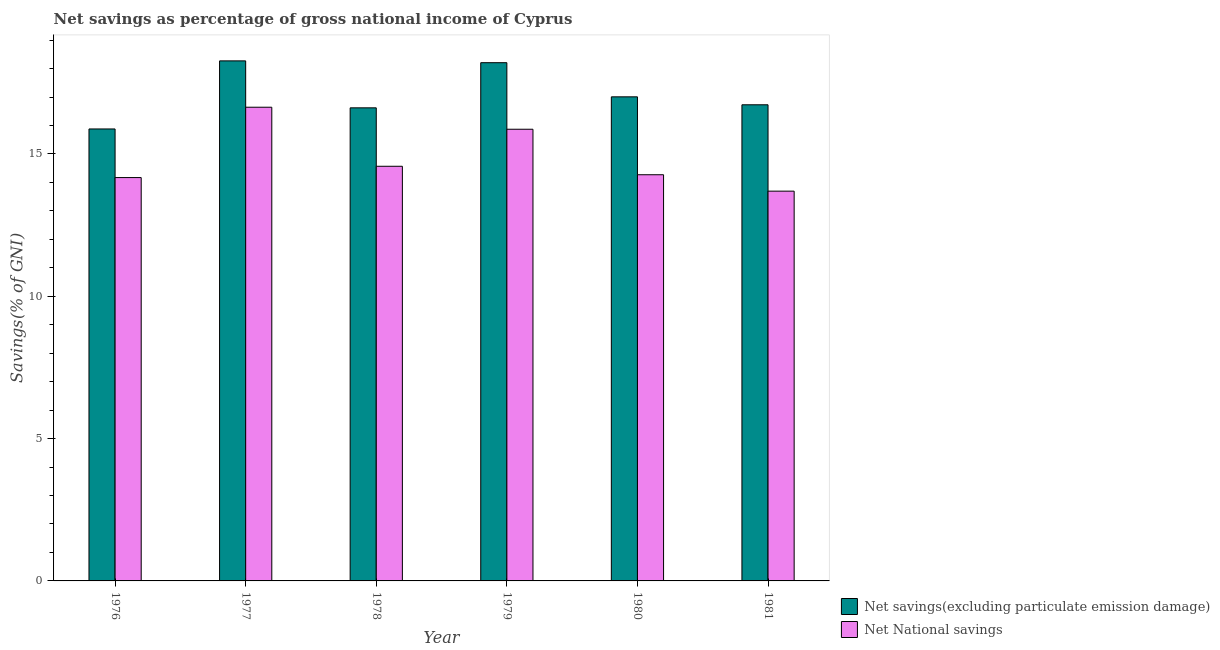How many different coloured bars are there?
Your answer should be very brief. 2. How many bars are there on the 5th tick from the left?
Provide a short and direct response. 2. How many bars are there on the 3rd tick from the right?
Keep it short and to the point. 2. What is the label of the 6th group of bars from the left?
Keep it short and to the point. 1981. What is the net savings(excluding particulate emission damage) in 1976?
Keep it short and to the point. 15.88. Across all years, what is the maximum net savings(excluding particulate emission damage)?
Your response must be concise. 18.27. Across all years, what is the minimum net savings(excluding particulate emission damage)?
Make the answer very short. 15.88. In which year was the net national savings maximum?
Give a very brief answer. 1977. What is the total net national savings in the graph?
Your response must be concise. 89.21. What is the difference between the net savings(excluding particulate emission damage) in 1976 and that in 1980?
Make the answer very short. -1.13. What is the difference between the net national savings in 1979 and the net savings(excluding particulate emission damage) in 1976?
Make the answer very short. 1.7. What is the average net national savings per year?
Your answer should be compact. 14.87. In the year 1981, what is the difference between the net savings(excluding particulate emission damage) and net national savings?
Provide a short and direct response. 0. What is the ratio of the net savings(excluding particulate emission damage) in 1976 to that in 1980?
Give a very brief answer. 0.93. Is the net national savings in 1976 less than that in 1980?
Make the answer very short. Yes. What is the difference between the highest and the second highest net savings(excluding particulate emission damage)?
Your answer should be very brief. 0.06. What is the difference between the highest and the lowest net savings(excluding particulate emission damage)?
Keep it short and to the point. 2.39. In how many years, is the net savings(excluding particulate emission damage) greater than the average net savings(excluding particulate emission damage) taken over all years?
Keep it short and to the point. 2. What does the 1st bar from the left in 1977 represents?
Ensure brevity in your answer.  Net savings(excluding particulate emission damage). What does the 2nd bar from the right in 1977 represents?
Offer a very short reply. Net savings(excluding particulate emission damage). Are the values on the major ticks of Y-axis written in scientific E-notation?
Offer a terse response. No. How many legend labels are there?
Your response must be concise. 2. What is the title of the graph?
Make the answer very short. Net savings as percentage of gross national income of Cyprus. Does "Secondary" appear as one of the legend labels in the graph?
Your answer should be very brief. No. What is the label or title of the X-axis?
Ensure brevity in your answer.  Year. What is the label or title of the Y-axis?
Offer a terse response. Savings(% of GNI). What is the Savings(% of GNI) of Net savings(excluding particulate emission damage) in 1976?
Your response must be concise. 15.88. What is the Savings(% of GNI) in Net National savings in 1976?
Offer a terse response. 14.17. What is the Savings(% of GNI) in Net savings(excluding particulate emission damage) in 1977?
Give a very brief answer. 18.27. What is the Savings(% of GNI) in Net National savings in 1977?
Give a very brief answer. 16.64. What is the Savings(% of GNI) of Net savings(excluding particulate emission damage) in 1978?
Your response must be concise. 16.62. What is the Savings(% of GNI) in Net National savings in 1978?
Provide a succinct answer. 14.57. What is the Savings(% of GNI) in Net savings(excluding particulate emission damage) in 1979?
Provide a succinct answer. 18.21. What is the Savings(% of GNI) of Net National savings in 1979?
Your response must be concise. 15.87. What is the Savings(% of GNI) of Net savings(excluding particulate emission damage) in 1980?
Provide a short and direct response. 17.01. What is the Savings(% of GNI) of Net National savings in 1980?
Provide a short and direct response. 14.27. What is the Savings(% of GNI) in Net savings(excluding particulate emission damage) in 1981?
Your answer should be very brief. 16.73. What is the Savings(% of GNI) in Net National savings in 1981?
Your answer should be very brief. 13.69. Across all years, what is the maximum Savings(% of GNI) of Net savings(excluding particulate emission damage)?
Give a very brief answer. 18.27. Across all years, what is the maximum Savings(% of GNI) of Net National savings?
Offer a very short reply. 16.64. Across all years, what is the minimum Savings(% of GNI) of Net savings(excluding particulate emission damage)?
Your answer should be compact. 15.88. Across all years, what is the minimum Savings(% of GNI) of Net National savings?
Give a very brief answer. 13.69. What is the total Savings(% of GNI) of Net savings(excluding particulate emission damage) in the graph?
Offer a very short reply. 102.71. What is the total Savings(% of GNI) in Net National savings in the graph?
Your answer should be very brief. 89.21. What is the difference between the Savings(% of GNI) of Net savings(excluding particulate emission damage) in 1976 and that in 1977?
Offer a terse response. -2.39. What is the difference between the Savings(% of GNI) in Net National savings in 1976 and that in 1977?
Ensure brevity in your answer.  -2.47. What is the difference between the Savings(% of GNI) of Net savings(excluding particulate emission damage) in 1976 and that in 1978?
Provide a succinct answer. -0.74. What is the difference between the Savings(% of GNI) in Net National savings in 1976 and that in 1978?
Offer a terse response. -0.4. What is the difference between the Savings(% of GNI) in Net savings(excluding particulate emission damage) in 1976 and that in 1979?
Give a very brief answer. -2.33. What is the difference between the Savings(% of GNI) of Net National savings in 1976 and that in 1979?
Offer a very short reply. -1.7. What is the difference between the Savings(% of GNI) of Net savings(excluding particulate emission damage) in 1976 and that in 1980?
Your answer should be compact. -1.13. What is the difference between the Savings(% of GNI) in Net National savings in 1976 and that in 1980?
Offer a very short reply. -0.1. What is the difference between the Savings(% of GNI) in Net savings(excluding particulate emission damage) in 1976 and that in 1981?
Your response must be concise. -0.85. What is the difference between the Savings(% of GNI) of Net National savings in 1976 and that in 1981?
Give a very brief answer. 0.48. What is the difference between the Savings(% of GNI) in Net savings(excluding particulate emission damage) in 1977 and that in 1978?
Provide a short and direct response. 1.65. What is the difference between the Savings(% of GNI) in Net National savings in 1977 and that in 1978?
Offer a very short reply. 2.07. What is the difference between the Savings(% of GNI) in Net savings(excluding particulate emission damage) in 1977 and that in 1979?
Your answer should be very brief. 0.06. What is the difference between the Savings(% of GNI) in Net National savings in 1977 and that in 1979?
Provide a short and direct response. 0.77. What is the difference between the Savings(% of GNI) of Net savings(excluding particulate emission damage) in 1977 and that in 1980?
Your response must be concise. 1.26. What is the difference between the Savings(% of GNI) of Net National savings in 1977 and that in 1980?
Provide a succinct answer. 2.37. What is the difference between the Savings(% of GNI) in Net savings(excluding particulate emission damage) in 1977 and that in 1981?
Provide a short and direct response. 1.54. What is the difference between the Savings(% of GNI) of Net National savings in 1977 and that in 1981?
Provide a short and direct response. 2.95. What is the difference between the Savings(% of GNI) of Net savings(excluding particulate emission damage) in 1978 and that in 1979?
Your answer should be very brief. -1.59. What is the difference between the Savings(% of GNI) in Net National savings in 1978 and that in 1979?
Your answer should be compact. -1.3. What is the difference between the Savings(% of GNI) of Net savings(excluding particulate emission damage) in 1978 and that in 1980?
Offer a very short reply. -0.39. What is the difference between the Savings(% of GNI) of Net National savings in 1978 and that in 1980?
Your answer should be compact. 0.3. What is the difference between the Savings(% of GNI) in Net savings(excluding particulate emission damage) in 1978 and that in 1981?
Provide a short and direct response. -0.11. What is the difference between the Savings(% of GNI) of Net National savings in 1978 and that in 1981?
Keep it short and to the point. 0.87. What is the difference between the Savings(% of GNI) in Net savings(excluding particulate emission damage) in 1979 and that in 1980?
Offer a terse response. 1.2. What is the difference between the Savings(% of GNI) of Net National savings in 1979 and that in 1980?
Keep it short and to the point. 1.6. What is the difference between the Savings(% of GNI) of Net savings(excluding particulate emission damage) in 1979 and that in 1981?
Keep it short and to the point. 1.48. What is the difference between the Savings(% of GNI) of Net National savings in 1979 and that in 1981?
Give a very brief answer. 2.17. What is the difference between the Savings(% of GNI) of Net savings(excluding particulate emission damage) in 1980 and that in 1981?
Ensure brevity in your answer.  0.28. What is the difference between the Savings(% of GNI) of Net National savings in 1980 and that in 1981?
Ensure brevity in your answer.  0.58. What is the difference between the Savings(% of GNI) of Net savings(excluding particulate emission damage) in 1976 and the Savings(% of GNI) of Net National savings in 1977?
Your answer should be compact. -0.76. What is the difference between the Savings(% of GNI) in Net savings(excluding particulate emission damage) in 1976 and the Savings(% of GNI) in Net National savings in 1978?
Offer a terse response. 1.31. What is the difference between the Savings(% of GNI) in Net savings(excluding particulate emission damage) in 1976 and the Savings(% of GNI) in Net National savings in 1979?
Ensure brevity in your answer.  0.01. What is the difference between the Savings(% of GNI) in Net savings(excluding particulate emission damage) in 1976 and the Savings(% of GNI) in Net National savings in 1980?
Provide a short and direct response. 1.61. What is the difference between the Savings(% of GNI) in Net savings(excluding particulate emission damage) in 1976 and the Savings(% of GNI) in Net National savings in 1981?
Provide a short and direct response. 2.19. What is the difference between the Savings(% of GNI) in Net savings(excluding particulate emission damage) in 1977 and the Savings(% of GNI) in Net National savings in 1978?
Keep it short and to the point. 3.7. What is the difference between the Savings(% of GNI) of Net savings(excluding particulate emission damage) in 1977 and the Savings(% of GNI) of Net National savings in 1979?
Your answer should be very brief. 2.4. What is the difference between the Savings(% of GNI) in Net savings(excluding particulate emission damage) in 1977 and the Savings(% of GNI) in Net National savings in 1980?
Offer a very short reply. 4. What is the difference between the Savings(% of GNI) in Net savings(excluding particulate emission damage) in 1977 and the Savings(% of GNI) in Net National savings in 1981?
Your response must be concise. 4.58. What is the difference between the Savings(% of GNI) of Net savings(excluding particulate emission damage) in 1978 and the Savings(% of GNI) of Net National savings in 1979?
Offer a very short reply. 0.75. What is the difference between the Savings(% of GNI) in Net savings(excluding particulate emission damage) in 1978 and the Savings(% of GNI) in Net National savings in 1980?
Your answer should be very brief. 2.35. What is the difference between the Savings(% of GNI) in Net savings(excluding particulate emission damage) in 1978 and the Savings(% of GNI) in Net National savings in 1981?
Give a very brief answer. 2.93. What is the difference between the Savings(% of GNI) in Net savings(excluding particulate emission damage) in 1979 and the Savings(% of GNI) in Net National savings in 1980?
Your answer should be very brief. 3.94. What is the difference between the Savings(% of GNI) of Net savings(excluding particulate emission damage) in 1979 and the Savings(% of GNI) of Net National savings in 1981?
Provide a succinct answer. 4.51. What is the difference between the Savings(% of GNI) of Net savings(excluding particulate emission damage) in 1980 and the Savings(% of GNI) of Net National savings in 1981?
Your answer should be compact. 3.31. What is the average Savings(% of GNI) of Net savings(excluding particulate emission damage) per year?
Your response must be concise. 17.12. What is the average Savings(% of GNI) in Net National savings per year?
Provide a short and direct response. 14.87. In the year 1976, what is the difference between the Savings(% of GNI) of Net savings(excluding particulate emission damage) and Savings(% of GNI) of Net National savings?
Provide a succinct answer. 1.71. In the year 1977, what is the difference between the Savings(% of GNI) of Net savings(excluding particulate emission damage) and Savings(% of GNI) of Net National savings?
Offer a very short reply. 1.63. In the year 1978, what is the difference between the Savings(% of GNI) of Net savings(excluding particulate emission damage) and Savings(% of GNI) of Net National savings?
Your answer should be compact. 2.05. In the year 1979, what is the difference between the Savings(% of GNI) in Net savings(excluding particulate emission damage) and Savings(% of GNI) in Net National savings?
Give a very brief answer. 2.34. In the year 1980, what is the difference between the Savings(% of GNI) of Net savings(excluding particulate emission damage) and Savings(% of GNI) of Net National savings?
Ensure brevity in your answer.  2.74. In the year 1981, what is the difference between the Savings(% of GNI) in Net savings(excluding particulate emission damage) and Savings(% of GNI) in Net National savings?
Provide a short and direct response. 3.03. What is the ratio of the Savings(% of GNI) of Net savings(excluding particulate emission damage) in 1976 to that in 1977?
Provide a succinct answer. 0.87. What is the ratio of the Savings(% of GNI) of Net National savings in 1976 to that in 1977?
Offer a terse response. 0.85. What is the ratio of the Savings(% of GNI) of Net savings(excluding particulate emission damage) in 1976 to that in 1978?
Make the answer very short. 0.96. What is the ratio of the Savings(% of GNI) in Net National savings in 1976 to that in 1978?
Give a very brief answer. 0.97. What is the ratio of the Savings(% of GNI) of Net savings(excluding particulate emission damage) in 1976 to that in 1979?
Your answer should be compact. 0.87. What is the ratio of the Savings(% of GNI) in Net National savings in 1976 to that in 1979?
Give a very brief answer. 0.89. What is the ratio of the Savings(% of GNI) of Net savings(excluding particulate emission damage) in 1976 to that in 1980?
Provide a succinct answer. 0.93. What is the ratio of the Savings(% of GNI) in Net savings(excluding particulate emission damage) in 1976 to that in 1981?
Your response must be concise. 0.95. What is the ratio of the Savings(% of GNI) of Net National savings in 1976 to that in 1981?
Ensure brevity in your answer.  1.03. What is the ratio of the Savings(% of GNI) of Net savings(excluding particulate emission damage) in 1977 to that in 1978?
Your response must be concise. 1.1. What is the ratio of the Savings(% of GNI) in Net National savings in 1977 to that in 1978?
Offer a very short reply. 1.14. What is the ratio of the Savings(% of GNI) of Net National savings in 1977 to that in 1979?
Offer a very short reply. 1.05. What is the ratio of the Savings(% of GNI) of Net savings(excluding particulate emission damage) in 1977 to that in 1980?
Offer a very short reply. 1.07. What is the ratio of the Savings(% of GNI) in Net National savings in 1977 to that in 1980?
Ensure brevity in your answer.  1.17. What is the ratio of the Savings(% of GNI) in Net savings(excluding particulate emission damage) in 1977 to that in 1981?
Your response must be concise. 1.09. What is the ratio of the Savings(% of GNI) of Net National savings in 1977 to that in 1981?
Offer a very short reply. 1.22. What is the ratio of the Savings(% of GNI) in Net savings(excluding particulate emission damage) in 1978 to that in 1979?
Offer a terse response. 0.91. What is the ratio of the Savings(% of GNI) in Net National savings in 1978 to that in 1979?
Make the answer very short. 0.92. What is the ratio of the Savings(% of GNI) in Net savings(excluding particulate emission damage) in 1978 to that in 1980?
Ensure brevity in your answer.  0.98. What is the ratio of the Savings(% of GNI) in Net National savings in 1978 to that in 1980?
Keep it short and to the point. 1.02. What is the ratio of the Savings(% of GNI) of Net savings(excluding particulate emission damage) in 1978 to that in 1981?
Your response must be concise. 0.99. What is the ratio of the Savings(% of GNI) in Net National savings in 1978 to that in 1981?
Offer a very short reply. 1.06. What is the ratio of the Savings(% of GNI) of Net savings(excluding particulate emission damage) in 1979 to that in 1980?
Make the answer very short. 1.07. What is the ratio of the Savings(% of GNI) of Net National savings in 1979 to that in 1980?
Keep it short and to the point. 1.11. What is the ratio of the Savings(% of GNI) in Net savings(excluding particulate emission damage) in 1979 to that in 1981?
Offer a very short reply. 1.09. What is the ratio of the Savings(% of GNI) of Net National savings in 1979 to that in 1981?
Offer a very short reply. 1.16. What is the ratio of the Savings(% of GNI) of Net savings(excluding particulate emission damage) in 1980 to that in 1981?
Offer a terse response. 1.02. What is the ratio of the Savings(% of GNI) in Net National savings in 1980 to that in 1981?
Ensure brevity in your answer.  1.04. What is the difference between the highest and the second highest Savings(% of GNI) in Net savings(excluding particulate emission damage)?
Offer a terse response. 0.06. What is the difference between the highest and the second highest Savings(% of GNI) of Net National savings?
Your answer should be compact. 0.77. What is the difference between the highest and the lowest Savings(% of GNI) in Net savings(excluding particulate emission damage)?
Provide a short and direct response. 2.39. What is the difference between the highest and the lowest Savings(% of GNI) in Net National savings?
Your response must be concise. 2.95. 